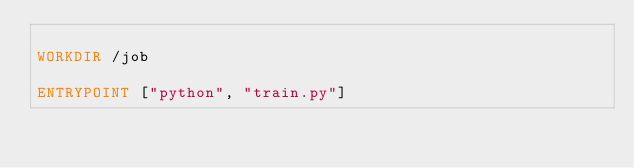<code> <loc_0><loc_0><loc_500><loc_500><_Dockerfile_>
WORKDIR /job

ENTRYPOINT ["python", "train.py"]
</code> 